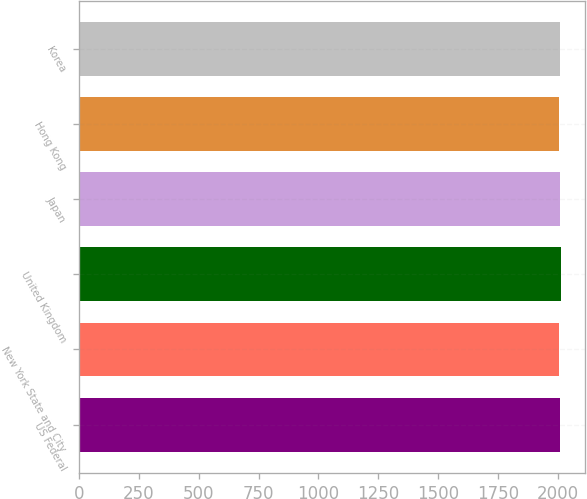Convert chart. <chart><loc_0><loc_0><loc_500><loc_500><bar_chart><fcel>US Federal<fcel>New York State and City<fcel>United Kingdom<fcel>Japan<fcel>Hong Kong<fcel>Korea<nl><fcel>2008<fcel>2007<fcel>2012<fcel>2010<fcel>2006<fcel>2010.6<nl></chart> 